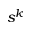<formula> <loc_0><loc_0><loc_500><loc_500>s ^ { k }</formula> 